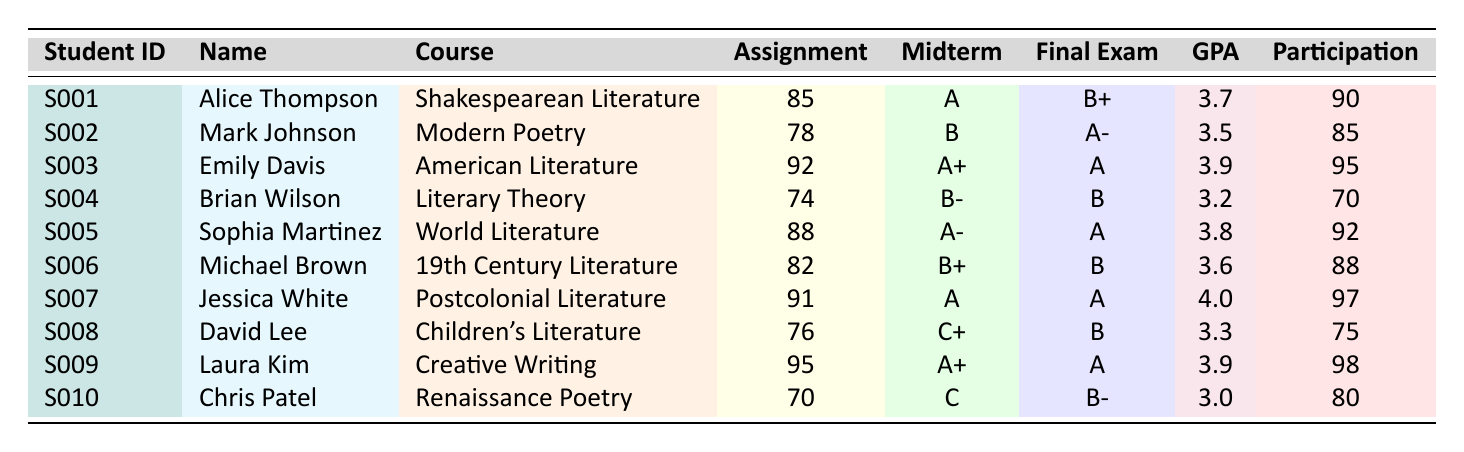What is the assignment score of Emily Davis? In the table, locate the row for Emily Davis. The assignment score listed next to her name is 92.
Answer: 92 Which student has the highest overall GPA? Review the GPA column in the table, and identify the maximum value. The highest GPA is 4.0, corresponding to Jessica White.
Answer: Jessica White What is the average assignment score of the students? To find the average, sum all assignment scores (85 + 78 + 92 + 74 + 88 + 82 + 91 + 76 + 95 + 70 =  829) and divide by the number of students (10). Thus, the average is 829 / 10 = 82.9.
Answer: 82.9 Did any student receive an A+ on both the midterm and final exam? Check the midterm and final exam grades for each student. Emily Davis and Laura Kim both received A+ on the midterm, but only Laura Kim received A on the final exam. Hence, no student received A+ in both assessments.
Answer: No What is the difference in participation scores between the highest and lowest scoring students? Identify the maximum participation score (98, Laura Kim) and the minimum participation score (70, Brian Wilson). Calculate the difference: 98 - 70 = 28.
Answer: 28 Are there any students who received a GPA below 3.5? Look through the GPA column. Identify students with a GPA below 3.5, which are Brian Wilson (3.2) and Chris Patel (3.0). Therefore, there are students with GPA below 3.5.
Answer: Yes What is the overall GPA of the student with the second-highest participation score? First, sort students based on participation scores. The two highest are Laura Kim (98) and Jessica White (97). Now look at the GPA of the second-highest, which is Jessica White with 4.0.
Answer: 4.0 Which course had the student with the lowest assignment score? Identify the lowest assignment score from the table, which is 70 (Chris Patel). The course associated with this score is Renaissance Poetry.
Answer: Renaissance Poetry If we consider only the students with a GPA of 3.5 or above, what is their average assignment score? First, extract the scores of students with GPA 3.5 or above: Alice (85), Mark (78), Emily (92), Sophia (88), Michael (82), Jessica (91), Laura (95). Then, sum these scores (85 + 78 + 92 + 88 + 82 + 91 + 95 = 511) and divide by 7 (the number of students): 511 / 7 = 73.0.
Answer: 73.0 How many students received a midterm grade of B or lower? Review the midterm grades for all students. The students with B or lower are Mark Johnson (B), Brian Wilson (B-), David Lee (C+), and Chris Patel (C). That's four students total.
Answer: 4 